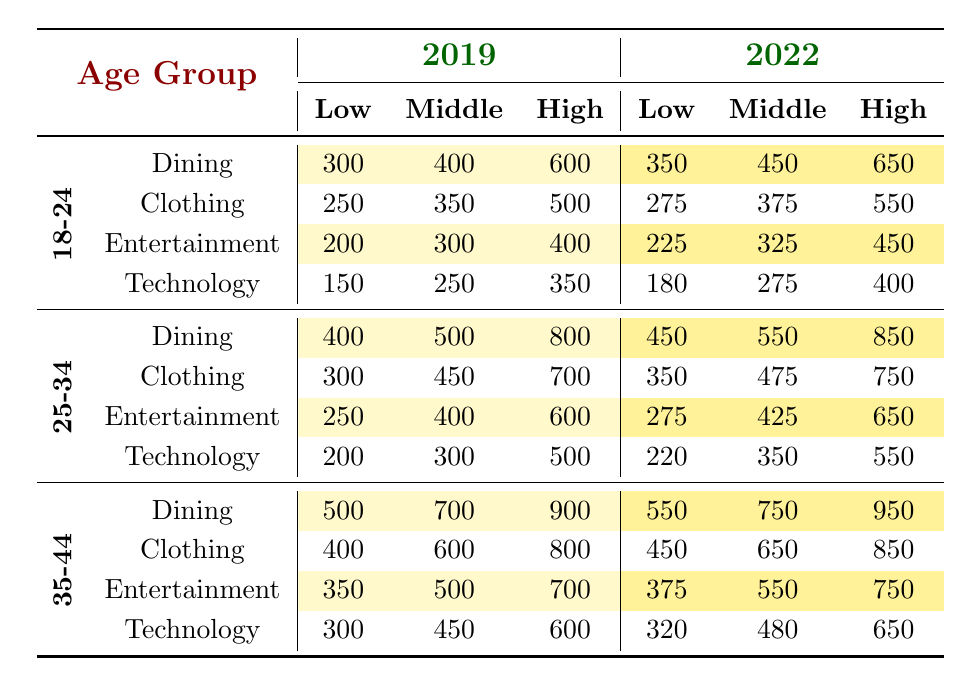What was the highest spending category for the 18-24 age group in 2022? Looking at the 18-24 age group's spending for 2022, the highest amount was in the Dining category at 650.
Answer: 650 What is the spending difference in the Dining category between the 25-34 age group for 2019 and 2022? In 2019, the spending for the 25-34 age group on Dining was 800, and in 2022, it was 850. The difference is 850 - 800 = 50.
Answer: 50 Did the average entertainment spending for the 35-44 age group increase from 2019 to 2022? In 2019, the Entertainment spending for the 35-44 age group was (350 + 500 + 700) / 3 = 516.67, and in 2022, it was (375 + 550 + 750) / 3 = 558.33. Since 558.33 > 516.67, it did increase.
Answer: Yes What is the total Technology spending for low-income individuals across all age groups in 2022? In 2022, the Technology spending for low-income individuals is 180 (age 18-24) + 220 (age 25-34) + 320 (age 35-44) = 720.
Answer: 720 Which age group had the highest average spending in the Clothing category for 2019? The spending for 2019 in the Clothing category was 250 (18-24), 450 (25-34), and 600 (35-44). The average for the 35-44 age group is the highest at 600.
Answer: 600 Is the Technology spending for the Income High group in 2022 higher than in 2019 for all age groups? In 2022, the Technology spending for Income High was 400 (18-24), 550 (25-34), 650 (35-44). In 2019, it was 350 (18-24), 500 (25-34), 600 (35-44). All comparisons show higher spending in 2022.
Answer: Yes What is the percentage increase in Dining spending for high-income individuals from 2019 to 2022 in the 35-44 age group? Dining spending for high-income individuals for the 35-44 age group was 900 in 2019 and 950 in 2022. The increase is (950 - 900) / 900 * 100 = 5.56%.
Answer: 5.56% Which age group showed the largest increase in Entertainment spending from 2019 to 2022 among low-income individuals? For low-income individuals, Entertainment spending was 200 (18-24), 250 (25-34), and 350 (35-44) in 2019 and 225 (18-24), 275 (25-34), 375 (35-44) in 2022. The largest increase for 35-44 (375 - 350 = 25).
Answer: 25 What was the average spending in the Clothing category for the 25-34 age group in 2022? The spending for the 25-34 age group in the Clothing category for 2022 was 350 (low) + 475 (middle) + 750 (high) = 1875, and the average is 1875 / 3 = 625.
Answer: 625 